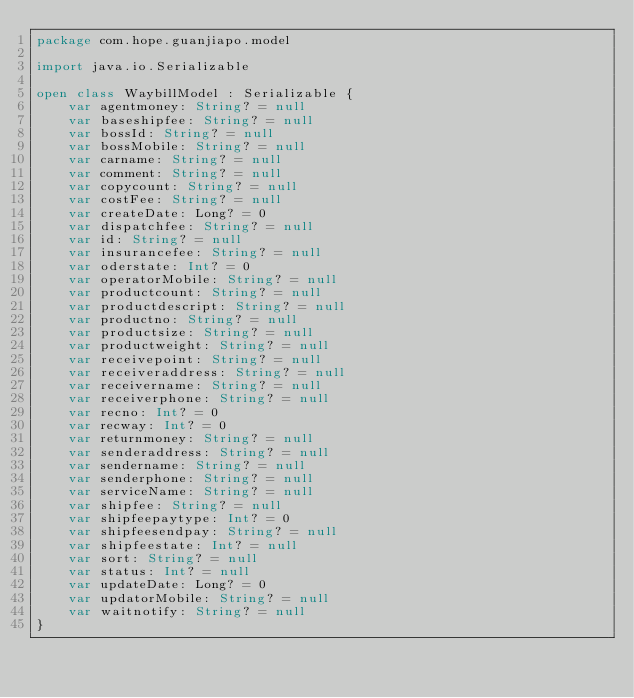<code> <loc_0><loc_0><loc_500><loc_500><_Kotlin_>package com.hope.guanjiapo.model

import java.io.Serializable

open class WaybillModel : Serializable {
    var agentmoney: String? = null
    var baseshipfee: String? = null
    var bossId: String? = null
    var bossMobile: String? = null
    var carname: String? = null
    var comment: String? = null
    var copycount: String? = null
    var costFee: String? = null
    var createDate: Long? = 0
    var dispatchfee: String? = null
    var id: String? = null
    var insurancefee: String? = null
    var oderstate: Int? = 0
    var operatorMobile: String? = null
    var productcount: String? = null
    var productdescript: String? = null
    var productno: String? = null
    var productsize: String? = null
    var productweight: String? = null
    var receivepoint: String? = null
    var receiveraddress: String? = null
    var receivername: String? = null
    var receiverphone: String? = null
    var recno: Int? = 0
    var recway: Int? = 0
    var returnmoney: String? = null
    var senderaddress: String? = null
    var sendername: String? = null
    var senderphone: String? = null
    var serviceName: String? = null
    var shipfee: String? = null
    var shipfeepaytype: Int? = 0
    var shipfeesendpay: String? = null
    var shipfeestate: Int? = null
    var sort: String? = null
    var status: Int? = null
    var updateDate: Long? = 0
    var updatorMobile: String? = null
    var waitnotify: String? = null
}
</code> 